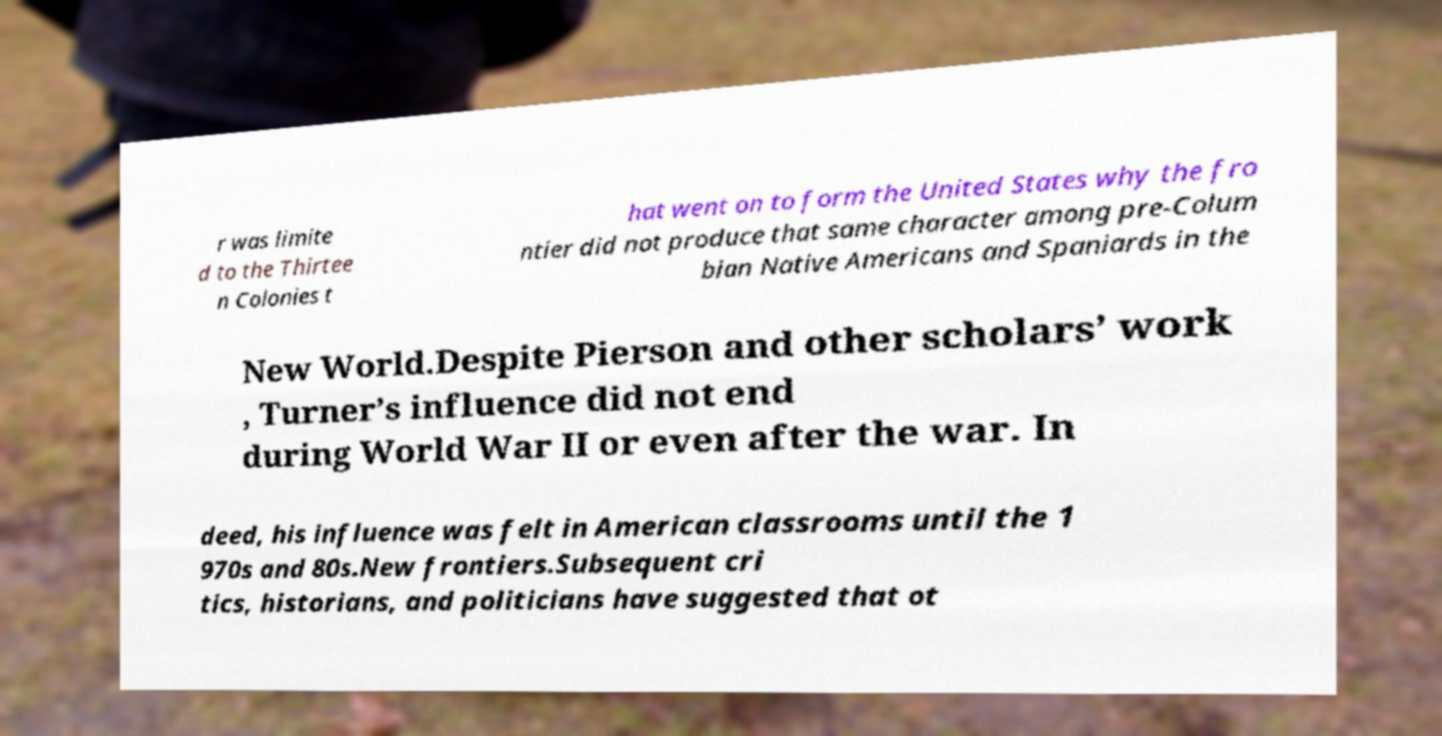For documentation purposes, I need the text within this image transcribed. Could you provide that? r was limite d to the Thirtee n Colonies t hat went on to form the United States why the fro ntier did not produce that same character among pre-Colum bian Native Americans and Spaniards in the New World.Despite Pierson and other scholars’ work , Turner’s influence did not end during World War II or even after the war. In deed, his influence was felt in American classrooms until the 1 970s and 80s.New frontiers.Subsequent cri tics, historians, and politicians have suggested that ot 